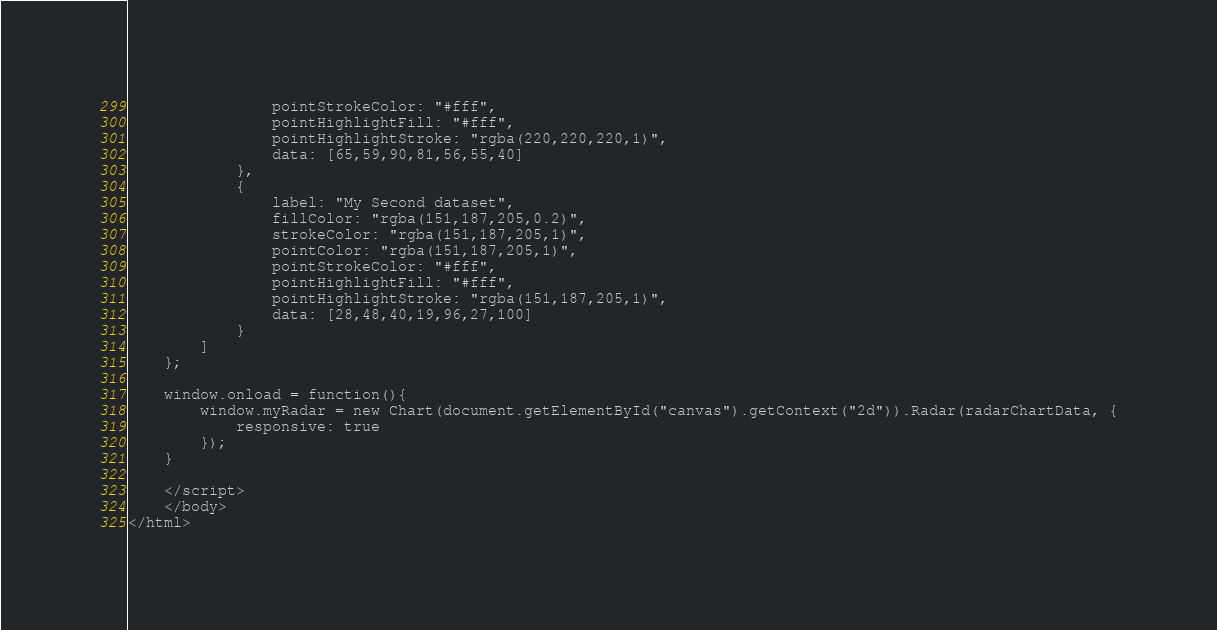Convert code to text. <code><loc_0><loc_0><loc_500><loc_500><_HTML_>				pointStrokeColor: "#fff",
				pointHighlightFill: "#fff",
				pointHighlightStroke: "rgba(220,220,220,1)",
				data: [65,59,90,81,56,55,40]
			},
			{
				label: "My Second dataset",
				fillColor: "rgba(151,187,205,0.2)",
				strokeColor: "rgba(151,187,205,1)",
				pointColor: "rgba(151,187,205,1)",
				pointStrokeColor: "#fff",
				pointHighlightFill: "#fff",
				pointHighlightStroke: "rgba(151,187,205,1)",
				data: [28,48,40,19,96,27,100]
			}
		]
	};

	window.onload = function(){
		window.myRadar = new Chart(document.getElementById("canvas").getContext("2d")).Radar(radarChartData, {
			responsive: true
		});
	}

	</script>
	</body>
</html>
</code> 